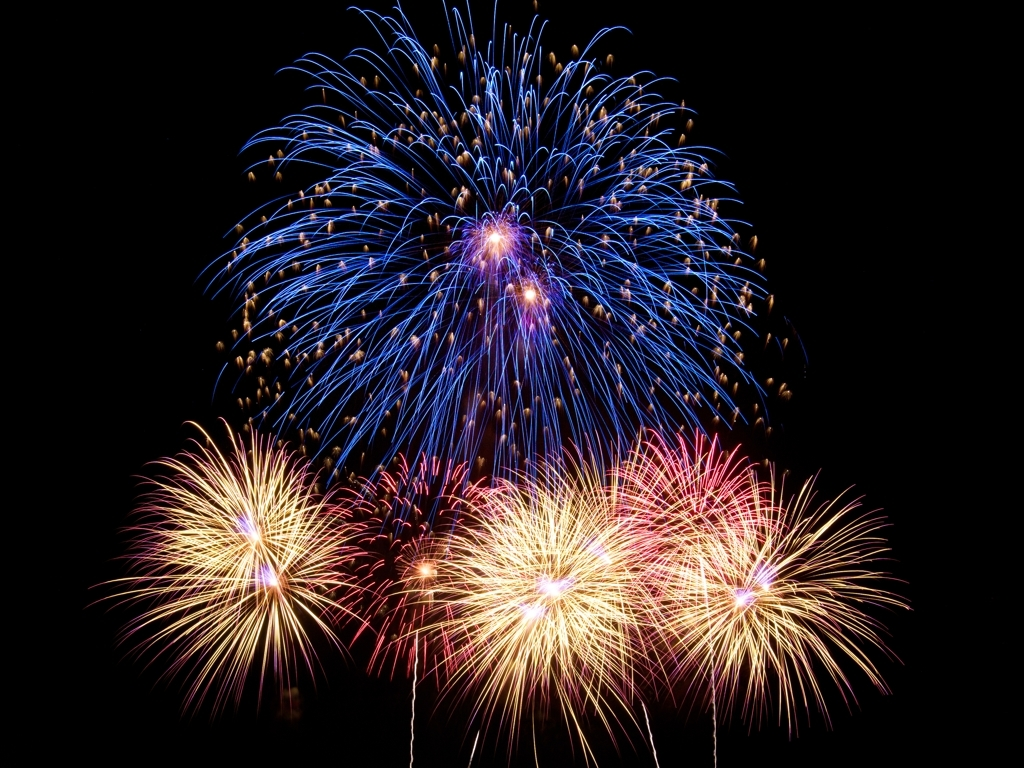Are there any quality issues with this image? The image is of high quality with vibrant colors and sharp detail, showcasing a beautiful display of fireworks against a dark sky. There do not appear to be any significant quality issues that detract from the visual experience. 